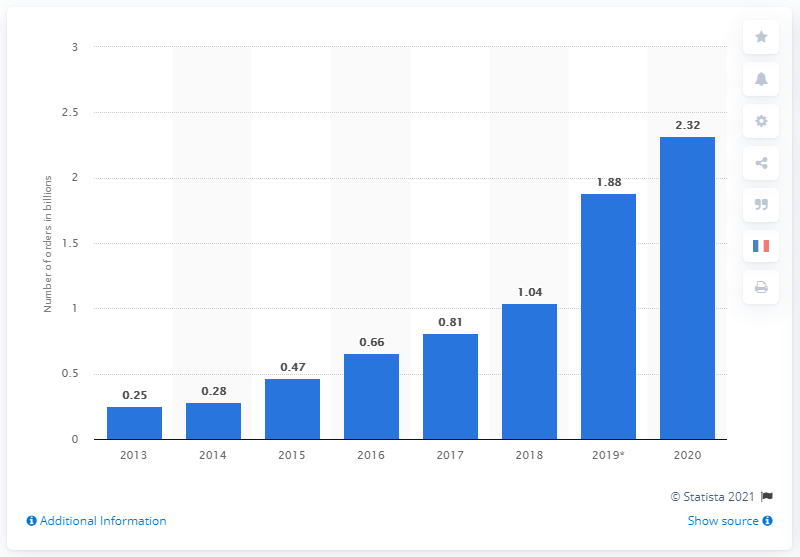List a handful of essential elements in this visual. During Alibaba's Singles Day sales, online shoppers placed a total of 2.32 orders on the Tmall and Taobao sites. 